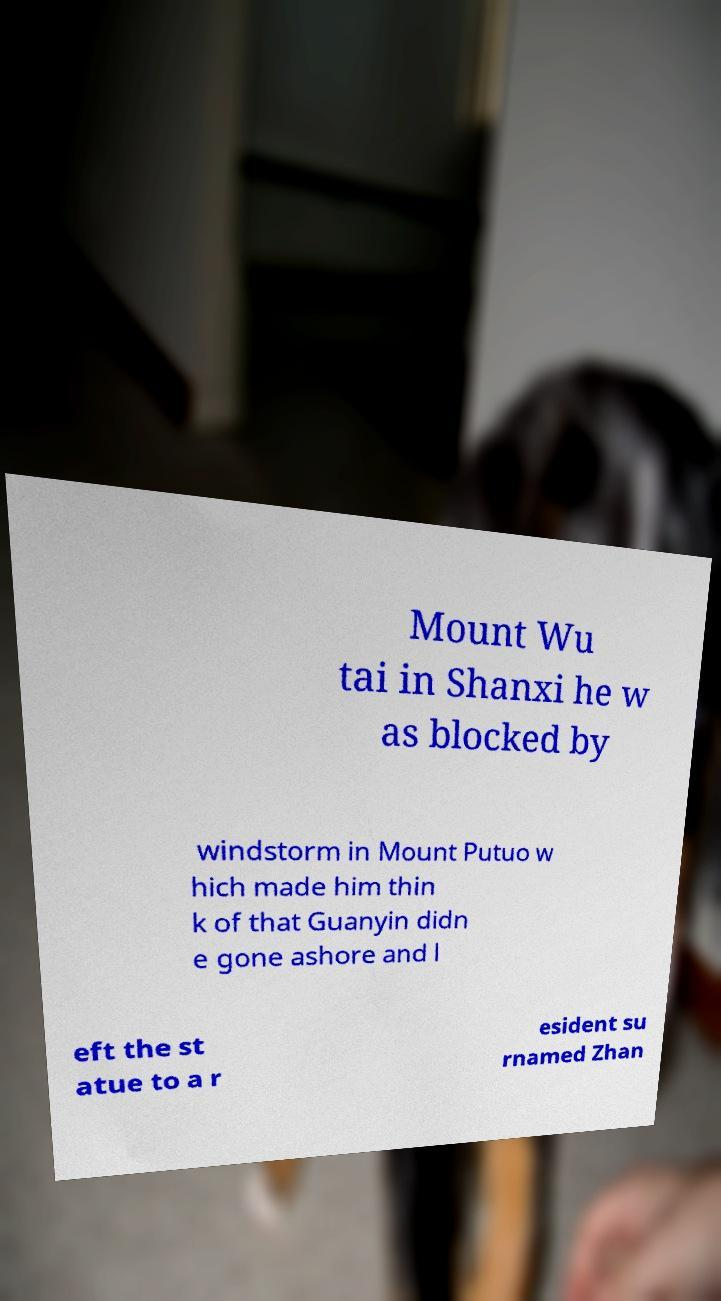There's text embedded in this image that I need extracted. Can you transcribe it verbatim? Mount Wu tai in Shanxi he w as blocked by windstorm in Mount Putuo w hich made him thin k of that Guanyin didn e gone ashore and l eft the st atue to a r esident su rnamed Zhan 